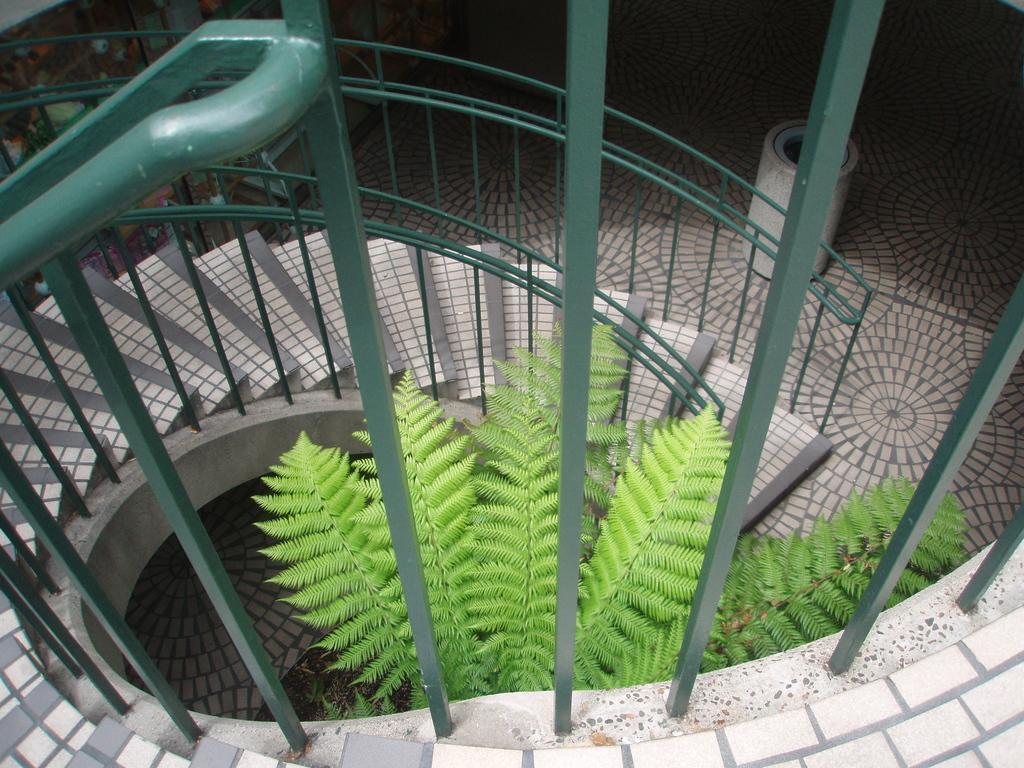Can you describe this image briefly? In the image there are stairs and in between the stairs there is a tree. 